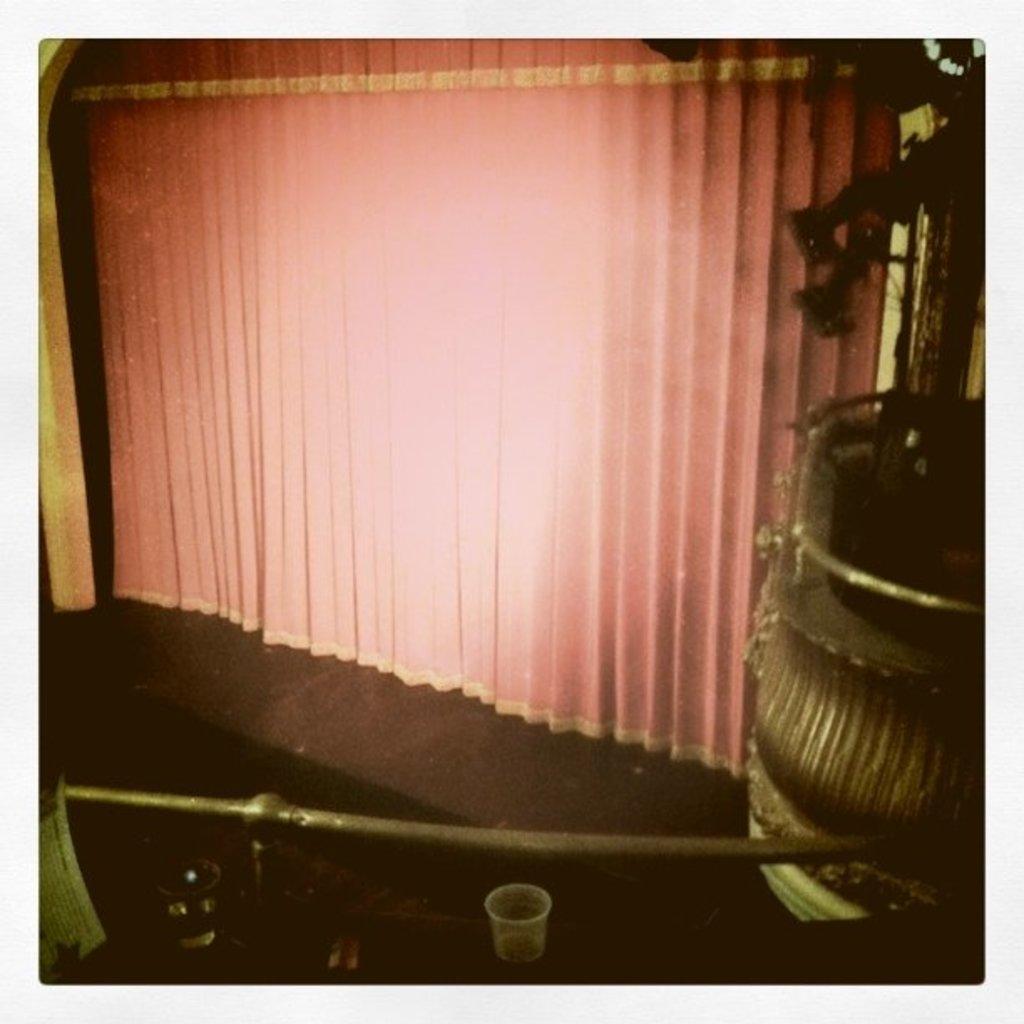Can you describe this image briefly? In this picture we can see glasses on the table, in the background we can find a plant and curtains. 